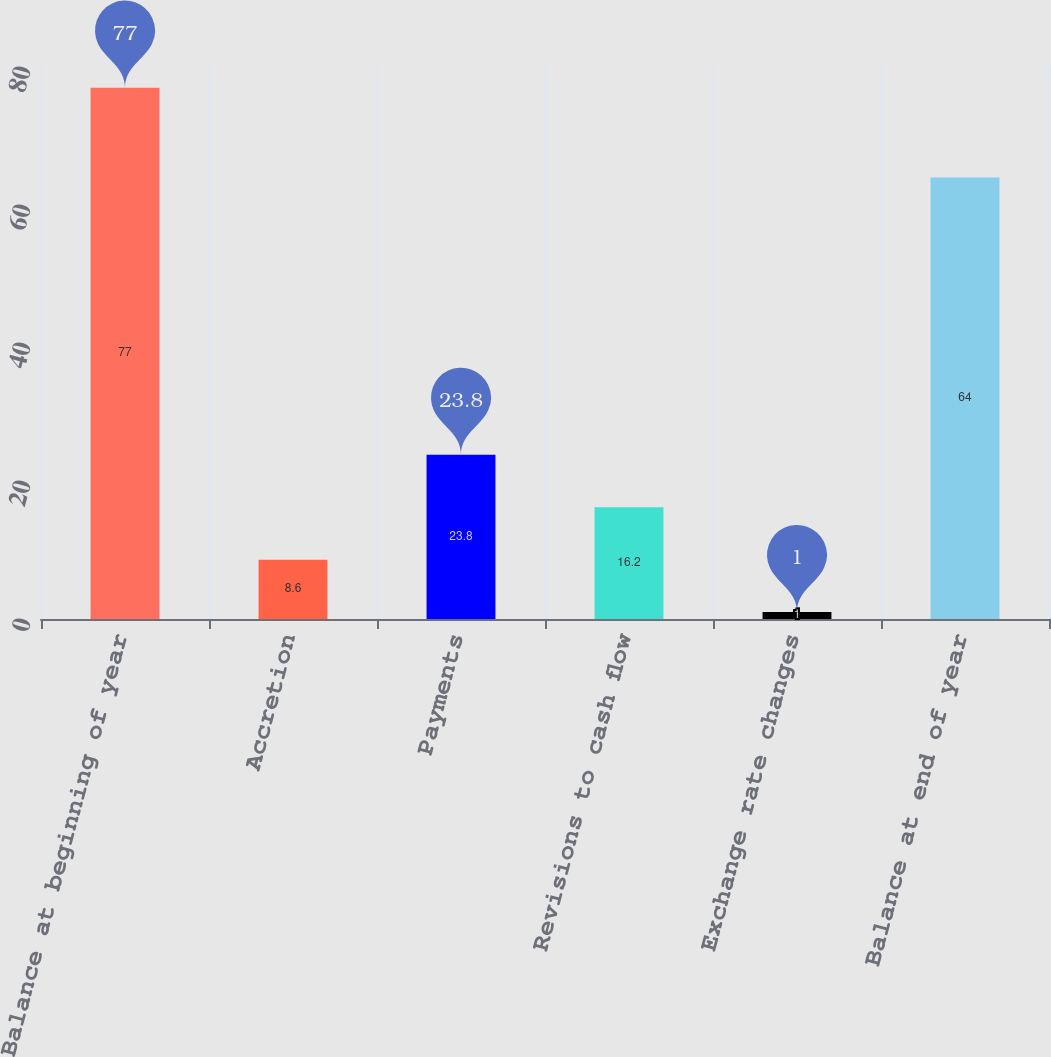Convert chart to OTSL. <chart><loc_0><loc_0><loc_500><loc_500><bar_chart><fcel>Balance at beginning of year<fcel>Accretion<fcel>Payments<fcel>Revisions to cash flow<fcel>Exchange rate changes<fcel>Balance at end of year<nl><fcel>77<fcel>8.6<fcel>23.8<fcel>16.2<fcel>1<fcel>64<nl></chart> 